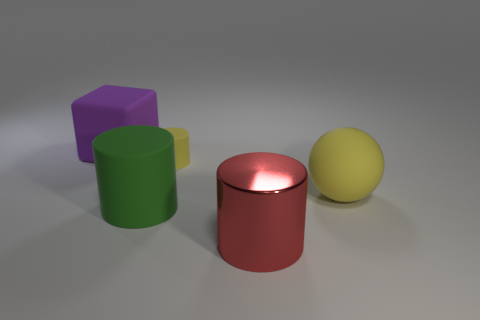Is there any other thing that has the same material as the big purple cube?
Your answer should be compact. Yes. Do the large object that is behind the large yellow thing and the tiny object have the same color?
Make the answer very short. No. What number of yellow objects are cylinders or large blocks?
Your response must be concise. 1. What number of other things are the same shape as the small object?
Keep it short and to the point. 2. Are the red thing and the large block made of the same material?
Your answer should be very brief. No. There is a cylinder that is right of the large green rubber object and behind the large shiny cylinder; what material is it?
Offer a terse response. Rubber. What color is the big matte thing that is behind the small rubber object?
Provide a succinct answer. Purple. Is the number of yellow cylinders that are in front of the tiny matte cylinder greater than the number of big purple shiny cubes?
Offer a very short reply. No. What number of other things are the same size as the purple cube?
Your response must be concise. 3. There is a green rubber object; what number of big spheres are in front of it?
Provide a succinct answer. 0. 